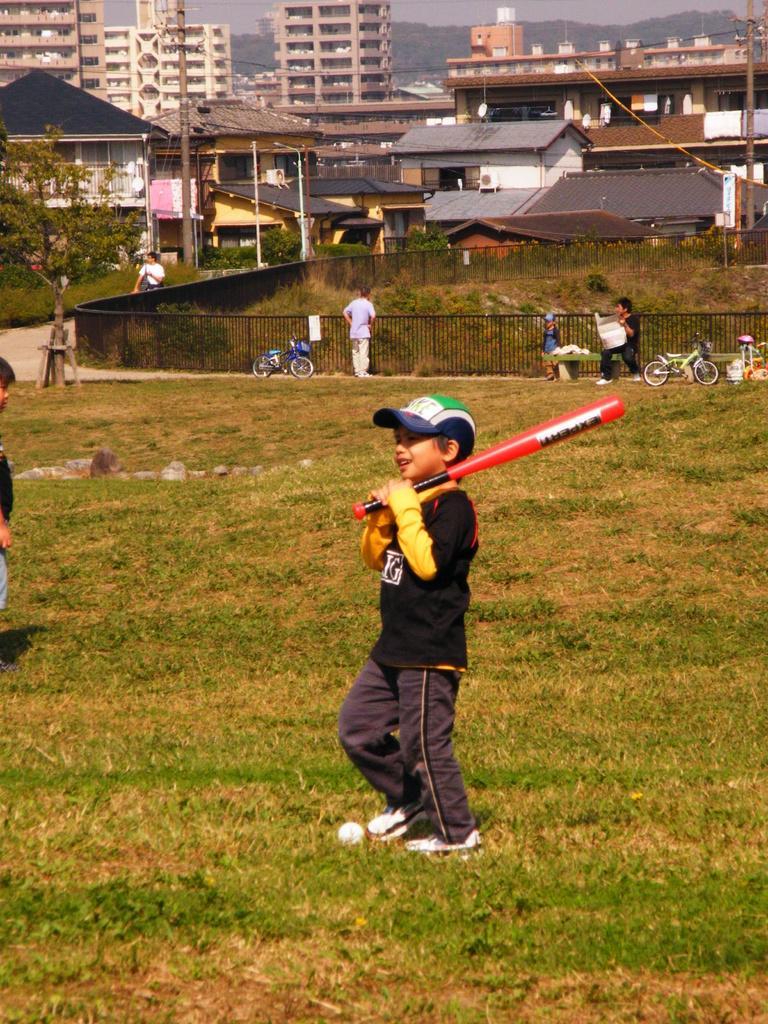How would you summarize this image in a sentence or two? Here we can see a boy is in motion on the ground by holding a bat in his hands and there is a ball on the ground at his legs. In the background there are few people,bicycles,fencehouses,trees,electric poles,wires,trees,mountains and sky. 